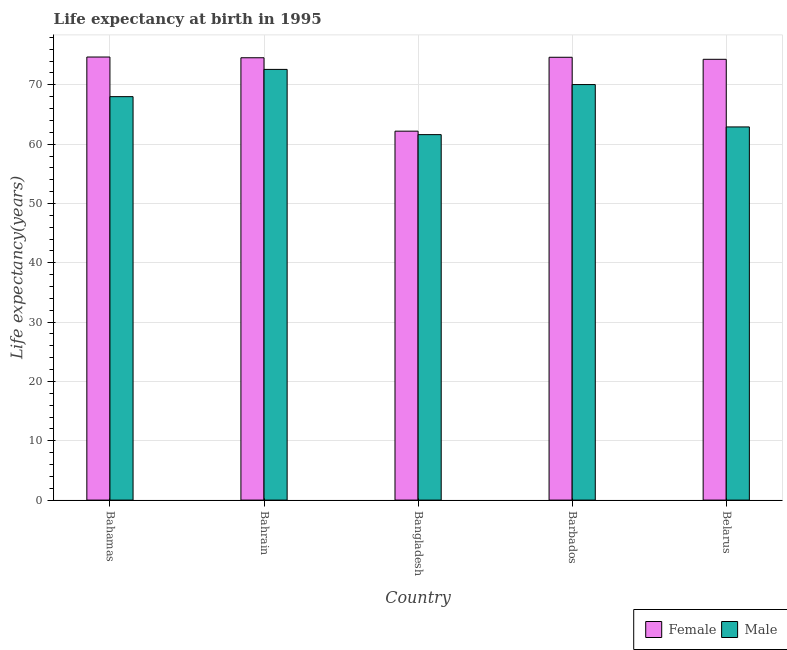How many bars are there on the 1st tick from the right?
Keep it short and to the point. 2. What is the life expectancy(female) in Bangladesh?
Keep it short and to the point. 62.19. Across all countries, what is the maximum life expectancy(male)?
Give a very brief answer. 72.6. Across all countries, what is the minimum life expectancy(female)?
Keep it short and to the point. 62.19. In which country was the life expectancy(male) maximum?
Your answer should be very brief. Bahrain. In which country was the life expectancy(male) minimum?
Ensure brevity in your answer.  Bangladesh. What is the total life expectancy(male) in the graph?
Your answer should be very brief. 335.15. What is the difference between the life expectancy(female) in Bangladesh and that in Barbados?
Provide a short and direct response. -12.45. What is the difference between the life expectancy(male) in Bahamas and the life expectancy(female) in Belarus?
Keep it short and to the point. -6.3. What is the average life expectancy(female) per country?
Provide a short and direct response. 72.07. What is the difference between the life expectancy(female) and life expectancy(male) in Bangladesh?
Your response must be concise. 0.58. What is the ratio of the life expectancy(female) in Bahamas to that in Bahrain?
Provide a succinct answer. 1. Is the difference between the life expectancy(female) in Bangladesh and Barbados greater than the difference between the life expectancy(male) in Bangladesh and Barbados?
Keep it short and to the point. No. What is the difference between the highest and the second highest life expectancy(female)?
Ensure brevity in your answer.  0.04. What is the difference between the highest and the lowest life expectancy(male)?
Make the answer very short. 10.99. In how many countries, is the life expectancy(female) greater than the average life expectancy(female) taken over all countries?
Provide a succinct answer. 4. Is the sum of the life expectancy(male) in Bahamas and Barbados greater than the maximum life expectancy(female) across all countries?
Your answer should be compact. Yes. What does the 1st bar from the left in Bahrain represents?
Keep it short and to the point. Female. How many bars are there?
Offer a terse response. 10. Are all the bars in the graph horizontal?
Ensure brevity in your answer.  No. What is the difference between two consecutive major ticks on the Y-axis?
Give a very brief answer. 10. Where does the legend appear in the graph?
Provide a short and direct response. Bottom right. How many legend labels are there?
Keep it short and to the point. 2. How are the legend labels stacked?
Offer a very short reply. Horizontal. What is the title of the graph?
Your answer should be very brief. Life expectancy at birth in 1995. What is the label or title of the X-axis?
Make the answer very short. Country. What is the label or title of the Y-axis?
Offer a very short reply. Life expectancy(years). What is the Life expectancy(years) of Female in Bahamas?
Your answer should be very brief. 74.68. What is the Life expectancy(years) of Male in Bahamas?
Provide a succinct answer. 68. What is the Life expectancy(years) in Female in Bahrain?
Your answer should be compact. 74.56. What is the Life expectancy(years) in Male in Bahrain?
Ensure brevity in your answer.  72.6. What is the Life expectancy(years) in Female in Bangladesh?
Provide a succinct answer. 62.19. What is the Life expectancy(years) in Male in Bangladesh?
Offer a terse response. 61.6. What is the Life expectancy(years) of Female in Barbados?
Provide a succinct answer. 74.64. What is the Life expectancy(years) of Male in Barbados?
Your response must be concise. 70.04. What is the Life expectancy(years) of Female in Belarus?
Provide a succinct answer. 74.3. What is the Life expectancy(years) in Male in Belarus?
Keep it short and to the point. 62.9. Across all countries, what is the maximum Life expectancy(years) of Female?
Give a very brief answer. 74.68. Across all countries, what is the maximum Life expectancy(years) in Male?
Ensure brevity in your answer.  72.6. Across all countries, what is the minimum Life expectancy(years) in Female?
Make the answer very short. 62.19. Across all countries, what is the minimum Life expectancy(years) in Male?
Provide a short and direct response. 61.6. What is the total Life expectancy(years) in Female in the graph?
Offer a very short reply. 360.37. What is the total Life expectancy(years) of Male in the graph?
Offer a very short reply. 335.15. What is the difference between the Life expectancy(years) of Female in Bahamas and that in Bahrain?
Your response must be concise. 0.12. What is the difference between the Life expectancy(years) of Male in Bahamas and that in Bahrain?
Your answer should be very brief. -4.59. What is the difference between the Life expectancy(years) in Female in Bahamas and that in Bangladesh?
Ensure brevity in your answer.  12.5. What is the difference between the Life expectancy(years) of Male in Bahamas and that in Bangladesh?
Keep it short and to the point. 6.4. What is the difference between the Life expectancy(years) in Female in Bahamas and that in Barbados?
Ensure brevity in your answer.  0.04. What is the difference between the Life expectancy(years) of Male in Bahamas and that in Barbados?
Your answer should be compact. -2.04. What is the difference between the Life expectancy(years) of Female in Bahamas and that in Belarus?
Make the answer very short. 0.38. What is the difference between the Life expectancy(years) of Male in Bahamas and that in Belarus?
Offer a terse response. 5.11. What is the difference between the Life expectancy(years) in Female in Bahrain and that in Bangladesh?
Give a very brief answer. 12.37. What is the difference between the Life expectancy(years) in Male in Bahrain and that in Bangladesh?
Offer a very short reply. 10.99. What is the difference between the Life expectancy(years) in Female in Bahrain and that in Barbados?
Offer a very short reply. -0.08. What is the difference between the Life expectancy(years) in Male in Bahrain and that in Barbados?
Provide a succinct answer. 2.56. What is the difference between the Life expectancy(years) in Female in Bahrain and that in Belarus?
Keep it short and to the point. 0.26. What is the difference between the Life expectancy(years) in Male in Bahrain and that in Belarus?
Make the answer very short. 9.7. What is the difference between the Life expectancy(years) of Female in Bangladesh and that in Barbados?
Provide a succinct answer. -12.46. What is the difference between the Life expectancy(years) in Male in Bangladesh and that in Barbados?
Offer a very short reply. -8.44. What is the difference between the Life expectancy(years) of Female in Bangladesh and that in Belarus?
Your answer should be very brief. -12.11. What is the difference between the Life expectancy(years) of Male in Bangladesh and that in Belarus?
Your answer should be very brief. -1.3. What is the difference between the Life expectancy(years) of Female in Barbados and that in Belarus?
Your answer should be very brief. 0.34. What is the difference between the Life expectancy(years) in Male in Barbados and that in Belarus?
Your answer should be compact. 7.14. What is the difference between the Life expectancy(years) of Female in Bahamas and the Life expectancy(years) of Male in Bahrain?
Ensure brevity in your answer.  2.08. What is the difference between the Life expectancy(years) in Female in Bahamas and the Life expectancy(years) in Male in Bangladesh?
Keep it short and to the point. 13.08. What is the difference between the Life expectancy(years) in Female in Bahamas and the Life expectancy(years) in Male in Barbados?
Offer a very short reply. 4.64. What is the difference between the Life expectancy(years) in Female in Bahamas and the Life expectancy(years) in Male in Belarus?
Your response must be concise. 11.78. What is the difference between the Life expectancy(years) in Female in Bahrain and the Life expectancy(years) in Male in Bangladesh?
Your answer should be very brief. 12.96. What is the difference between the Life expectancy(years) in Female in Bahrain and the Life expectancy(years) in Male in Barbados?
Make the answer very short. 4.52. What is the difference between the Life expectancy(years) of Female in Bahrain and the Life expectancy(years) of Male in Belarus?
Ensure brevity in your answer.  11.66. What is the difference between the Life expectancy(years) in Female in Bangladesh and the Life expectancy(years) in Male in Barbados?
Your answer should be compact. -7.85. What is the difference between the Life expectancy(years) in Female in Bangladesh and the Life expectancy(years) in Male in Belarus?
Keep it short and to the point. -0.71. What is the difference between the Life expectancy(years) in Female in Barbados and the Life expectancy(years) in Male in Belarus?
Make the answer very short. 11.74. What is the average Life expectancy(years) in Female per country?
Your answer should be compact. 72.07. What is the average Life expectancy(years) in Male per country?
Offer a very short reply. 67.03. What is the difference between the Life expectancy(years) of Female and Life expectancy(years) of Male in Bahamas?
Offer a terse response. 6.68. What is the difference between the Life expectancy(years) of Female and Life expectancy(years) of Male in Bahrain?
Offer a very short reply. 1.96. What is the difference between the Life expectancy(years) in Female and Life expectancy(years) in Male in Bangladesh?
Give a very brief answer. 0.58. What is the difference between the Life expectancy(years) in Female and Life expectancy(years) in Male in Barbados?
Give a very brief answer. 4.6. What is the difference between the Life expectancy(years) in Female and Life expectancy(years) in Male in Belarus?
Offer a very short reply. 11.4. What is the ratio of the Life expectancy(years) in Female in Bahamas to that in Bahrain?
Offer a very short reply. 1. What is the ratio of the Life expectancy(years) in Male in Bahamas to that in Bahrain?
Offer a very short reply. 0.94. What is the ratio of the Life expectancy(years) in Female in Bahamas to that in Bangladesh?
Provide a succinct answer. 1.2. What is the ratio of the Life expectancy(years) in Male in Bahamas to that in Bangladesh?
Give a very brief answer. 1.1. What is the ratio of the Life expectancy(years) of Female in Bahamas to that in Barbados?
Provide a short and direct response. 1. What is the ratio of the Life expectancy(years) in Male in Bahamas to that in Barbados?
Your response must be concise. 0.97. What is the ratio of the Life expectancy(years) of Female in Bahamas to that in Belarus?
Make the answer very short. 1.01. What is the ratio of the Life expectancy(years) in Male in Bahamas to that in Belarus?
Keep it short and to the point. 1.08. What is the ratio of the Life expectancy(years) in Female in Bahrain to that in Bangladesh?
Offer a terse response. 1.2. What is the ratio of the Life expectancy(years) in Male in Bahrain to that in Bangladesh?
Offer a terse response. 1.18. What is the ratio of the Life expectancy(years) of Female in Bahrain to that in Barbados?
Your response must be concise. 1. What is the ratio of the Life expectancy(years) in Male in Bahrain to that in Barbados?
Keep it short and to the point. 1.04. What is the ratio of the Life expectancy(years) in Male in Bahrain to that in Belarus?
Provide a succinct answer. 1.15. What is the ratio of the Life expectancy(years) of Female in Bangladesh to that in Barbados?
Offer a terse response. 0.83. What is the ratio of the Life expectancy(years) in Male in Bangladesh to that in Barbados?
Your answer should be compact. 0.88. What is the ratio of the Life expectancy(years) in Female in Bangladesh to that in Belarus?
Make the answer very short. 0.84. What is the ratio of the Life expectancy(years) in Male in Bangladesh to that in Belarus?
Provide a succinct answer. 0.98. What is the ratio of the Life expectancy(years) of Male in Barbados to that in Belarus?
Ensure brevity in your answer.  1.11. What is the difference between the highest and the second highest Life expectancy(years) in Female?
Make the answer very short. 0.04. What is the difference between the highest and the second highest Life expectancy(years) in Male?
Ensure brevity in your answer.  2.56. What is the difference between the highest and the lowest Life expectancy(years) of Female?
Ensure brevity in your answer.  12.5. What is the difference between the highest and the lowest Life expectancy(years) in Male?
Provide a short and direct response. 10.99. 